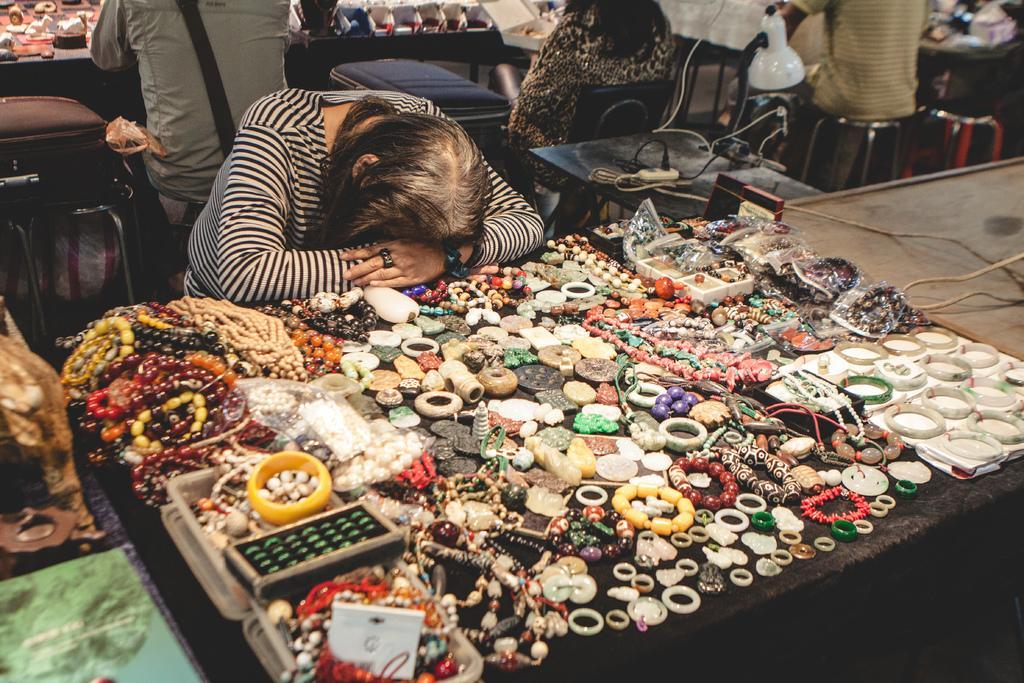Can you describe this image briefly? In this image there is a woman places her head and hand on the table, on which there are some ornaments. Behind her there are a few more people standing and sitting in front of their table on which there are objects, in the middle of them there are few cables are placed on the table. 